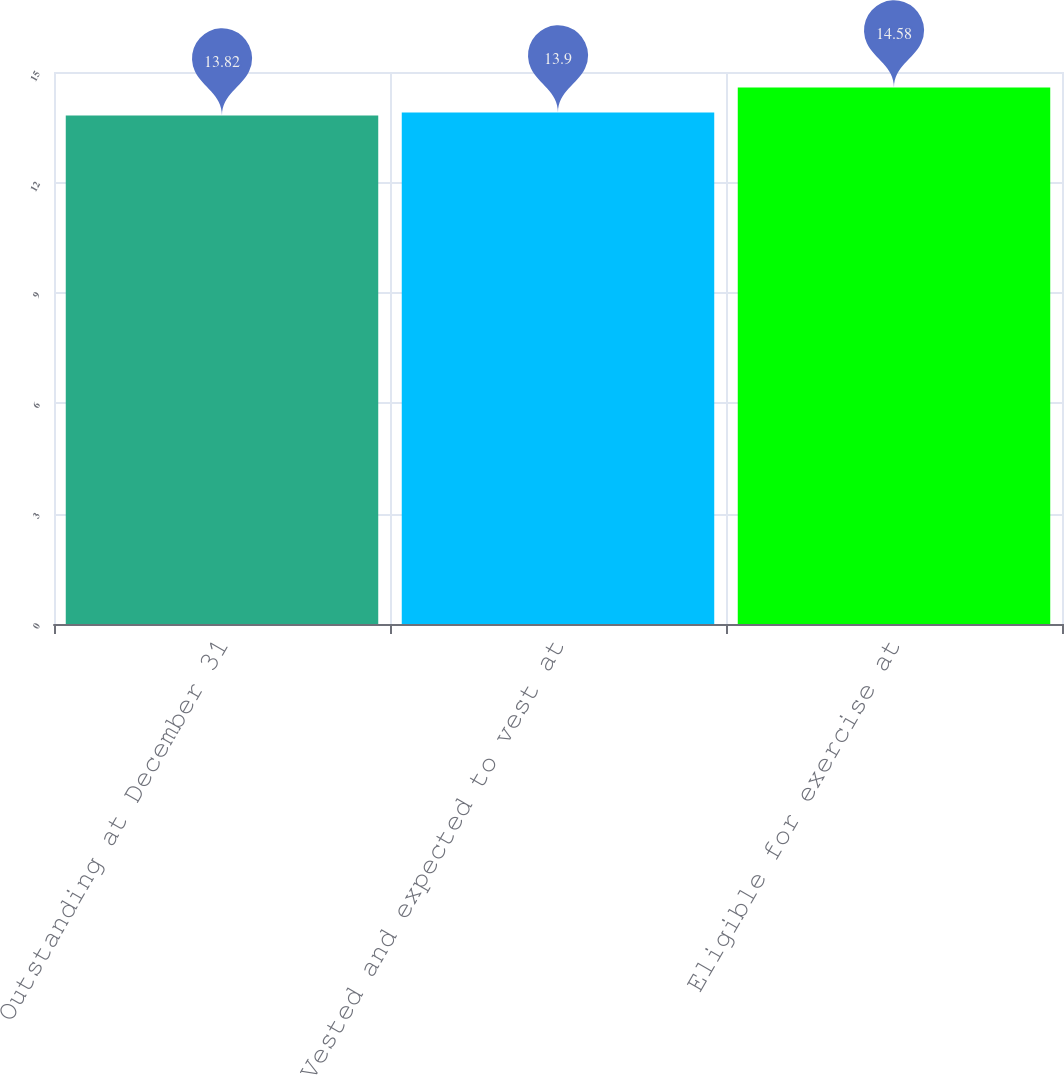<chart> <loc_0><loc_0><loc_500><loc_500><bar_chart><fcel>Outstanding at December 31<fcel>Vested and expected to vest at<fcel>Eligible for exercise at<nl><fcel>13.82<fcel>13.9<fcel>14.58<nl></chart> 